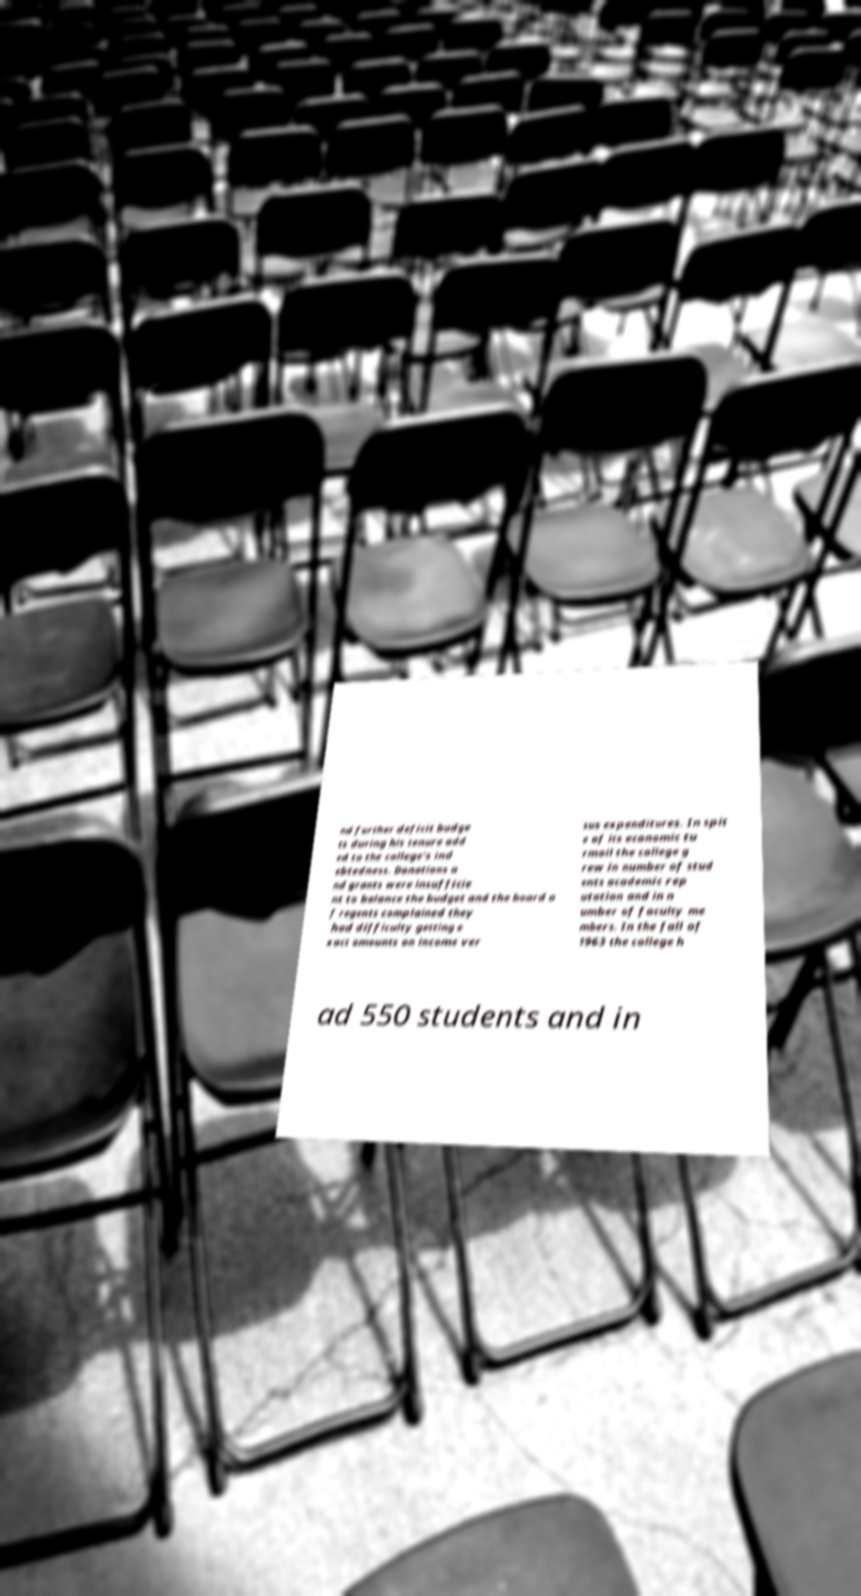What messages or text are displayed in this image? I need them in a readable, typed format. nd further deficit budge ts during his tenure add ed to the college's ind ebtedness. Donations a nd grants were insufficie nt to balance the budget and the board o f regents complained they had difficulty getting e xact amounts on income ver sus expenditures. In spit e of its economic tu rmoil the college g rew in number of stud ents academic rep utation and in n umber of faculty me mbers. In the fall of 1963 the college h ad 550 students and in 